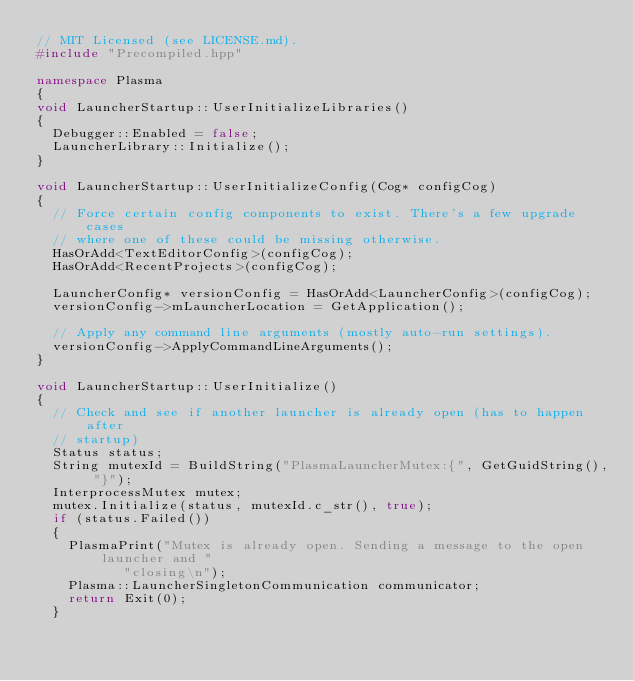<code> <loc_0><loc_0><loc_500><loc_500><_C++_>// MIT Licensed (see LICENSE.md).
#include "Precompiled.hpp"

namespace Plasma
{
void LauncherStartup::UserInitializeLibraries()
{
  Debugger::Enabled = false;
  LauncherLibrary::Initialize();
}

void LauncherStartup::UserInitializeConfig(Cog* configCog)
{
  // Force certain config components to exist. There's a few upgrade cases
  // where one of these could be missing otherwise.
  HasOrAdd<TextEditorConfig>(configCog);
  HasOrAdd<RecentProjects>(configCog);

  LauncherConfig* versionConfig = HasOrAdd<LauncherConfig>(configCog);
  versionConfig->mLauncherLocation = GetApplication();

  // Apply any command line arguments (mostly auto-run settings).
  versionConfig->ApplyCommandLineArguments();
}

void LauncherStartup::UserInitialize()
{
  // Check and see if another launcher is already open (has to happen after
  // startup)
  Status status;
  String mutexId = BuildString("PlasmaLauncherMutex:{", GetGuidString(), "}");
  InterprocessMutex mutex;
  mutex.Initialize(status, mutexId.c_str(), true);
  if (status.Failed())
  {
    PlasmaPrint("Mutex is already open. Sending a message to the open launcher and "
           "closing\n");
    Plasma::LauncherSingletonCommunication communicator;
    return Exit(0);
  }
</code> 